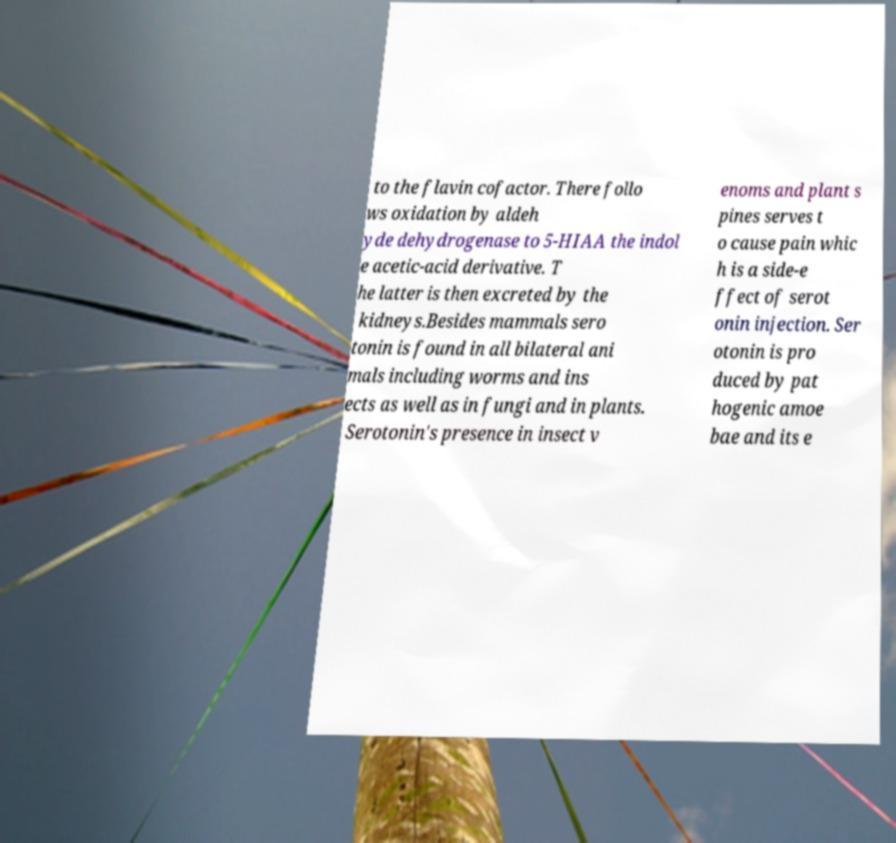What messages or text are displayed in this image? I need them in a readable, typed format. to the flavin cofactor. There follo ws oxidation by aldeh yde dehydrogenase to 5-HIAA the indol e acetic-acid derivative. T he latter is then excreted by the kidneys.Besides mammals sero tonin is found in all bilateral ani mals including worms and ins ects as well as in fungi and in plants. Serotonin's presence in insect v enoms and plant s pines serves t o cause pain whic h is a side-e ffect of serot onin injection. Ser otonin is pro duced by pat hogenic amoe bae and its e 